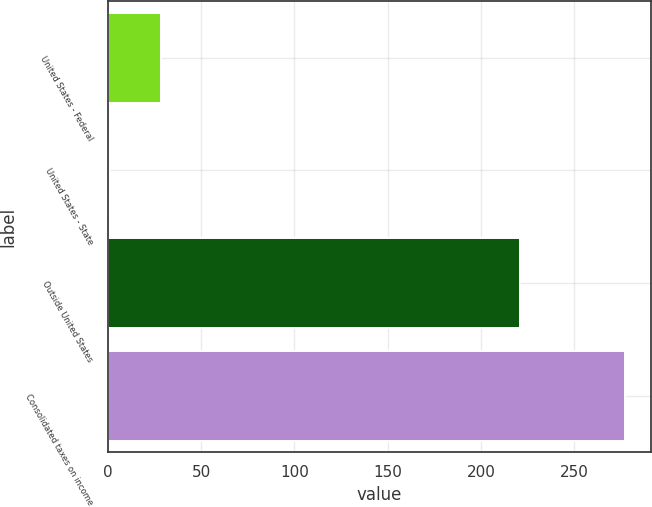Convert chart. <chart><loc_0><loc_0><loc_500><loc_500><bar_chart><fcel>United States - Federal<fcel>United States - State<fcel>Outside United States<fcel>Consolidated taxes on income<nl><fcel>28.6<fcel>1<fcel>221<fcel>277<nl></chart> 